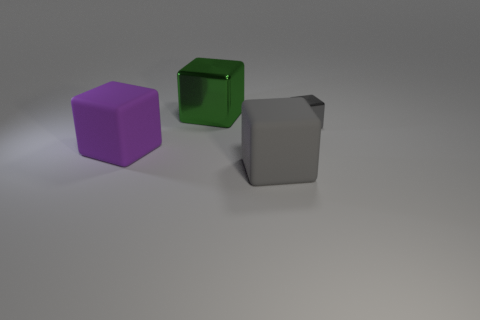Subtract all gray rubber blocks. How many blocks are left? 3 Subtract all brown balls. How many gray blocks are left? 2 Add 3 small blue balls. How many objects exist? 7 Subtract all purple blocks. How many blocks are left? 3 Subtract all red cubes. Subtract all blue cylinders. How many cubes are left? 4 Add 3 small things. How many small things are left? 4 Add 2 cyan matte objects. How many cyan matte objects exist? 2 Subtract 0 brown spheres. How many objects are left? 4 Subtract all big green metal things. Subtract all large gray objects. How many objects are left? 2 